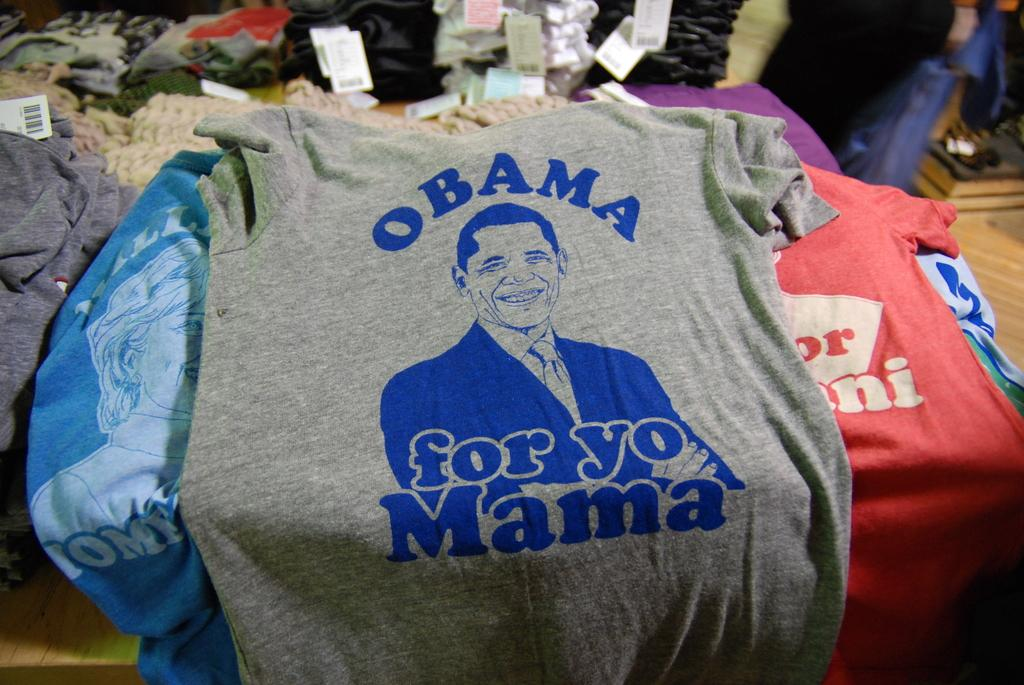What type of clothing is featured in the image? There are t-shirts in the image. What is depicted on the t-shirts? The t-shirts have a picture of a person in the middle. Are there any words or phrases on the t-shirts? Yes, there is text written on the t-shirts. What type of leather material can be seen on the t-shirts in the image? There is no leather material present on the t-shirts in the image. 